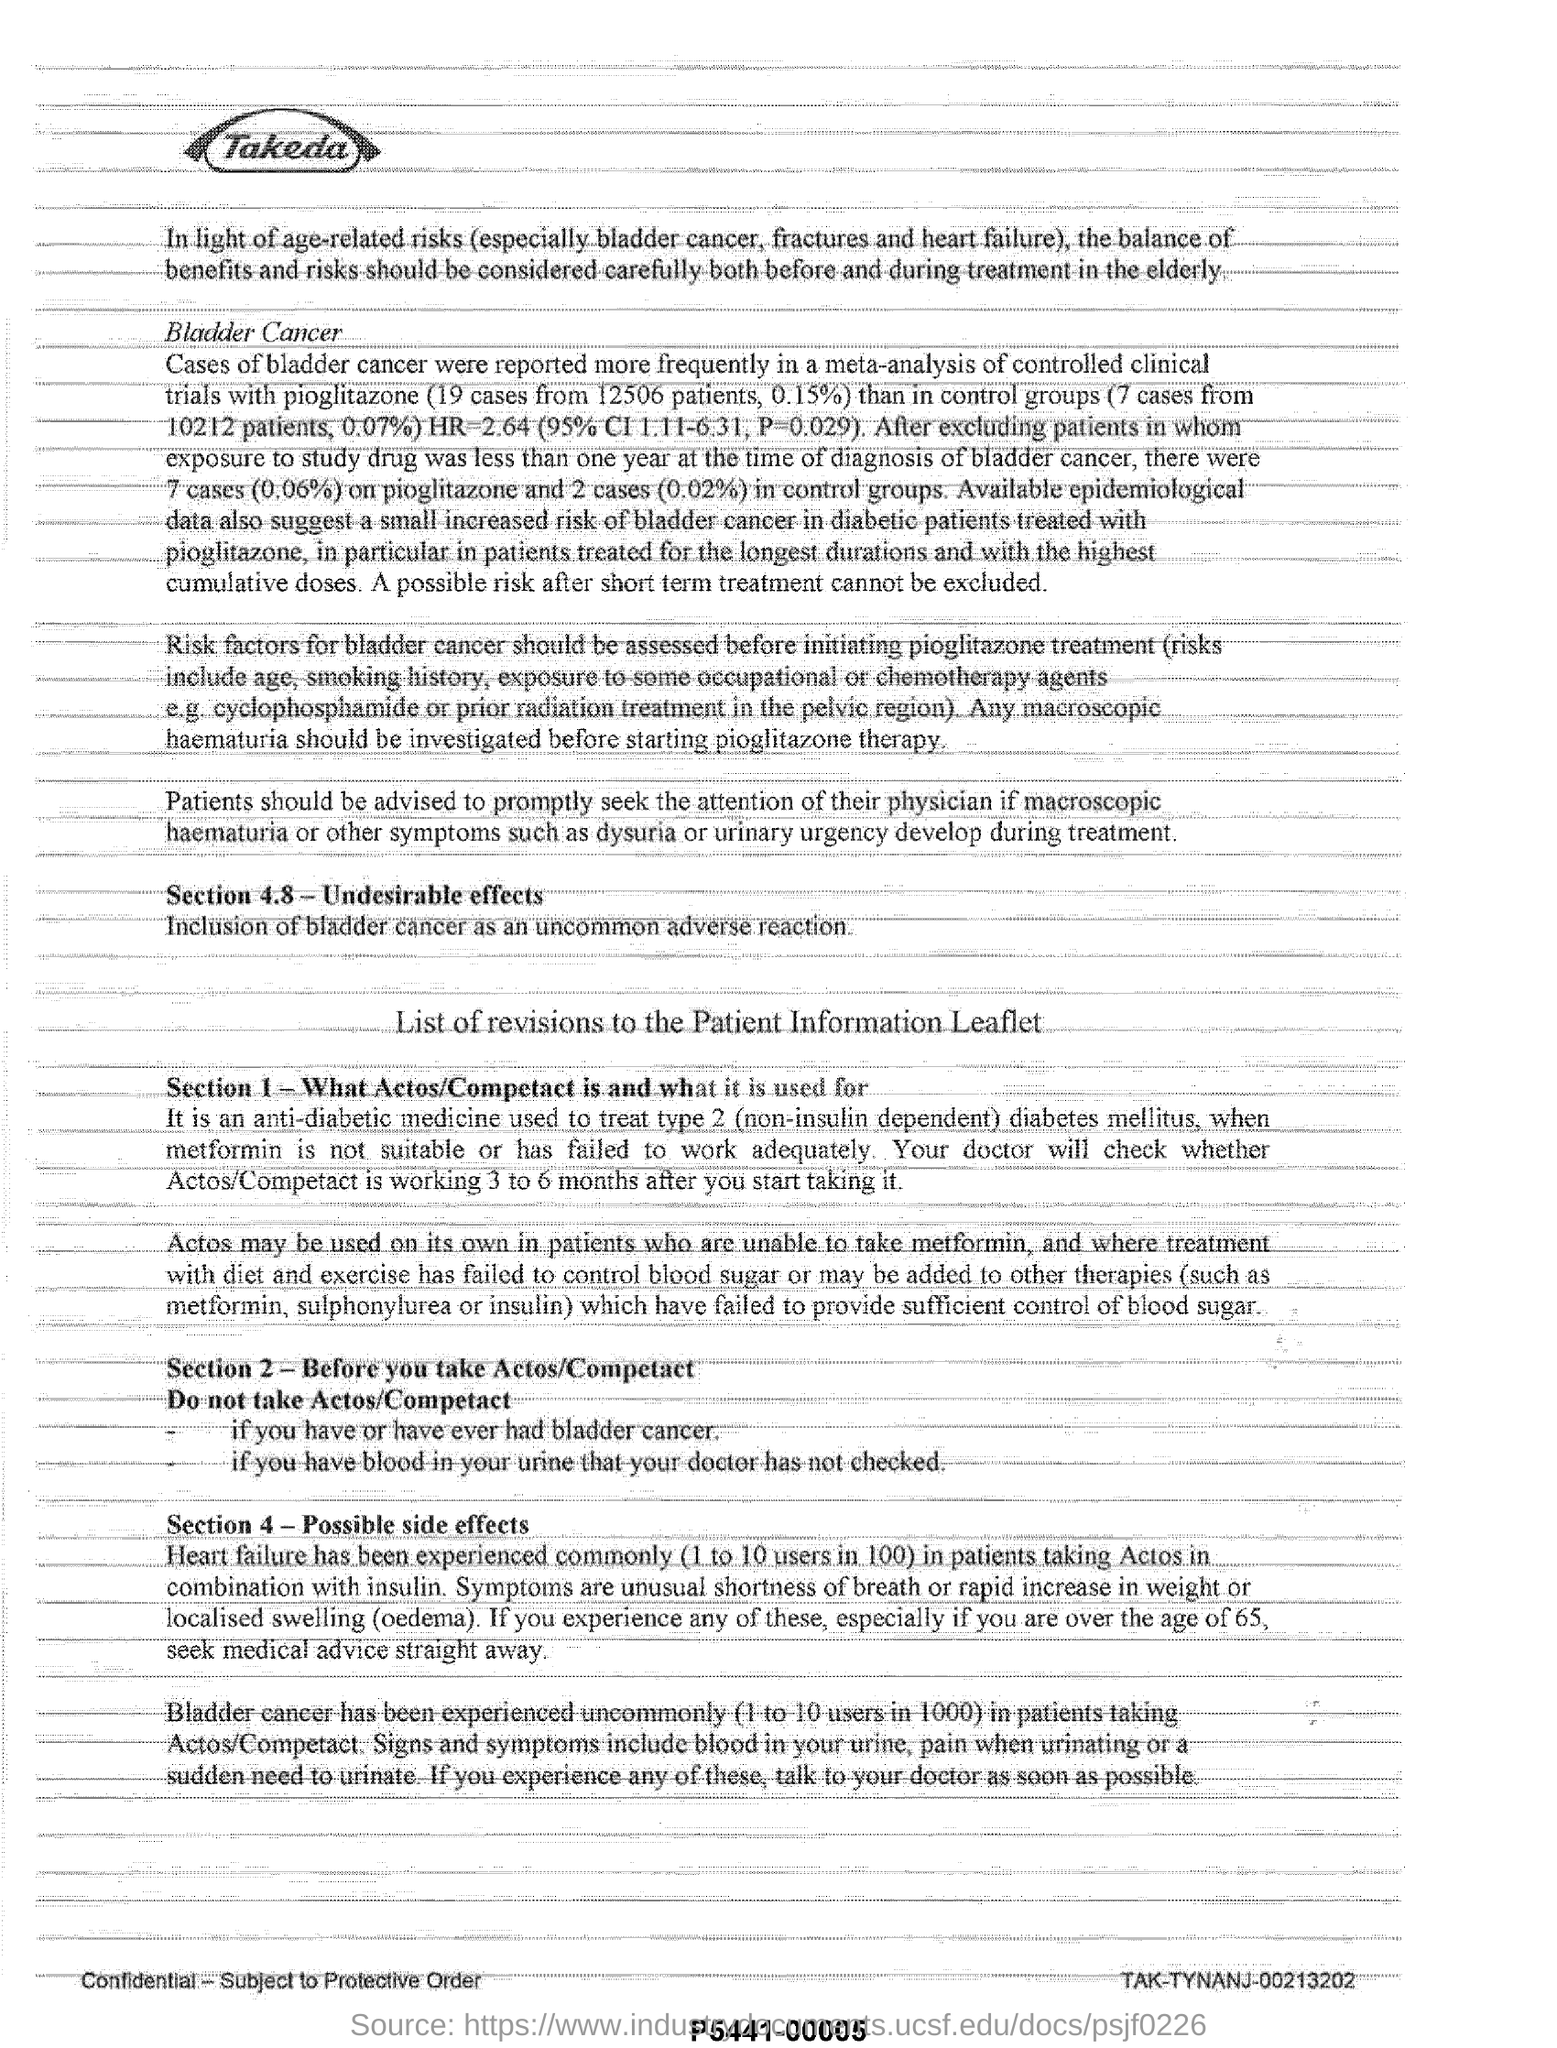What has to be investigated before starting pioglitazone therapy?
Your answer should be compact. Any macroscopic haematuria. What has been experienced commonly in patients taking actos in combination with insulin?
Offer a terse response. Heart failure. Which medicine is used to treat type 2 diabetes mellitus?
Provide a short and direct response. Actos/Competact. How many cases of bladder cancer from 12506 patients were reported?
Give a very brief answer. 19 cases. 